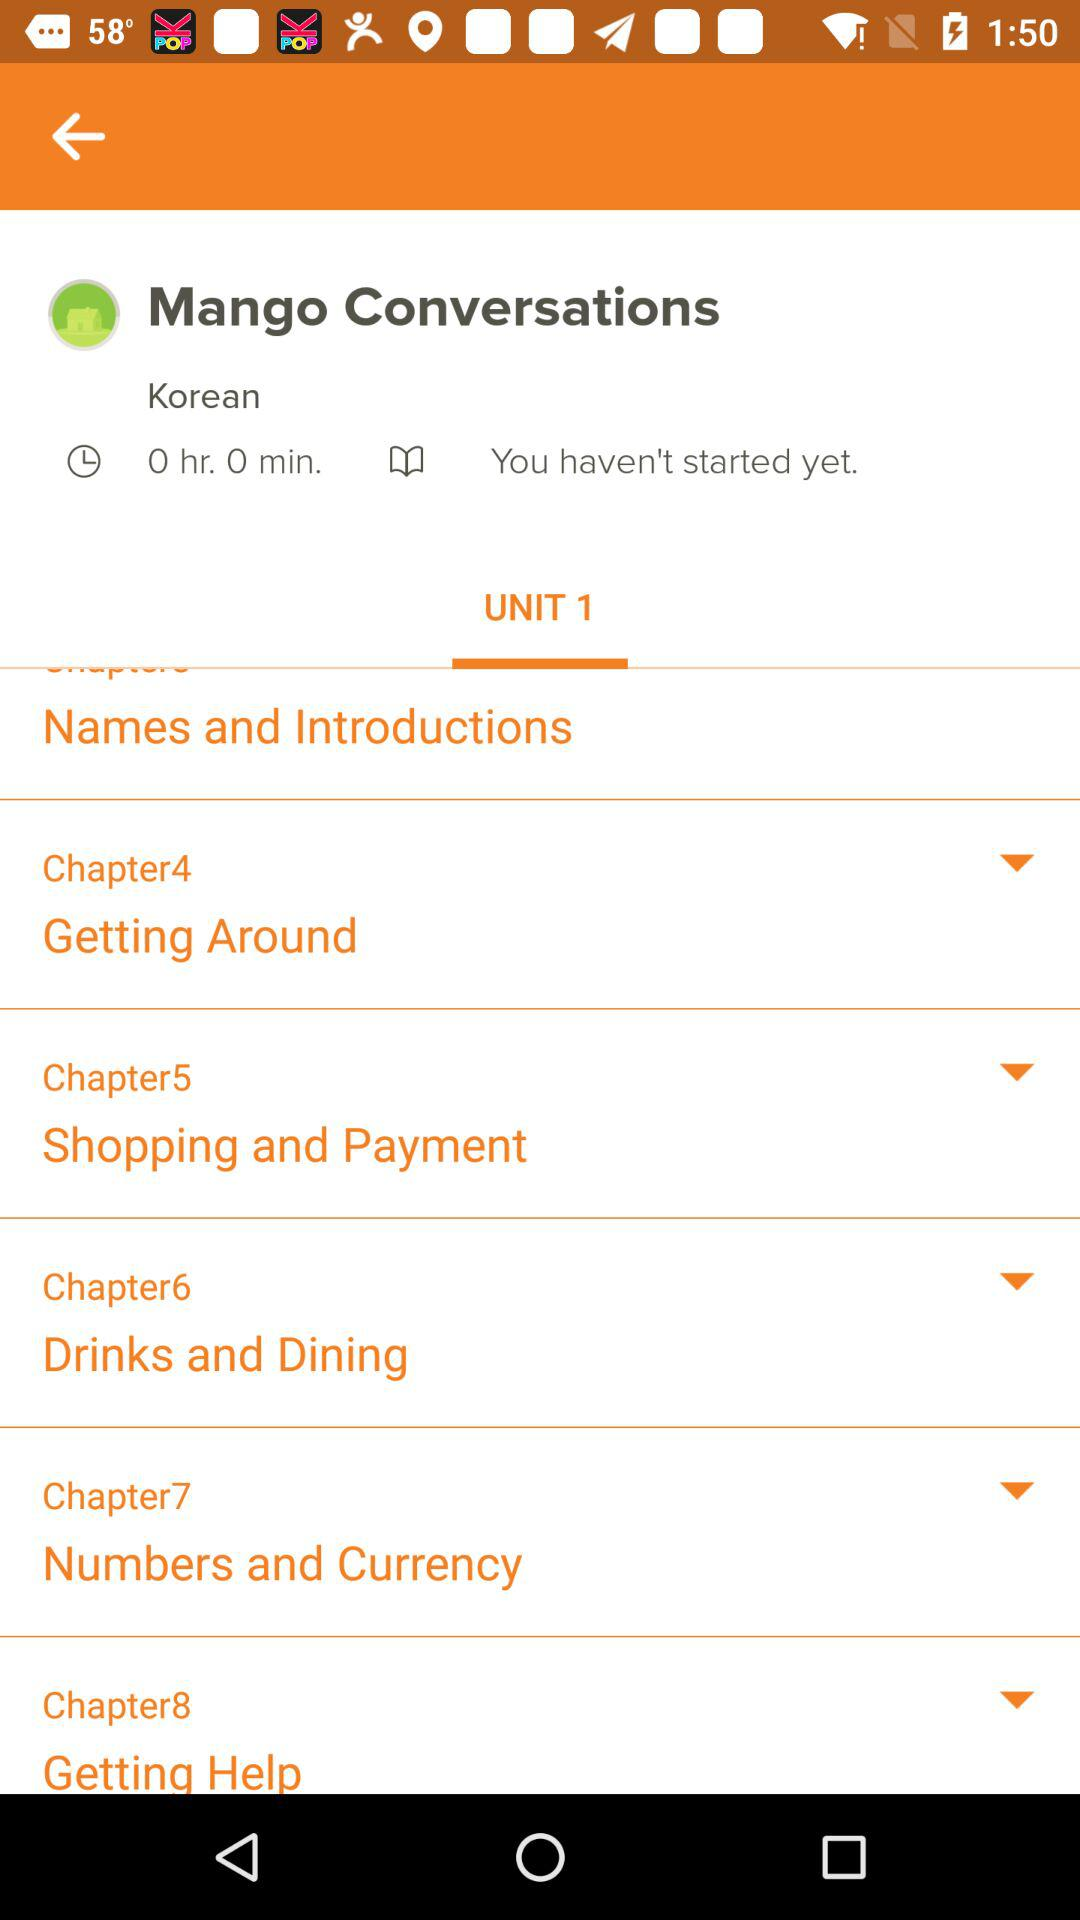What is the duration for "Mango Conversations"? The duration is 0 hours 0 minutes. 